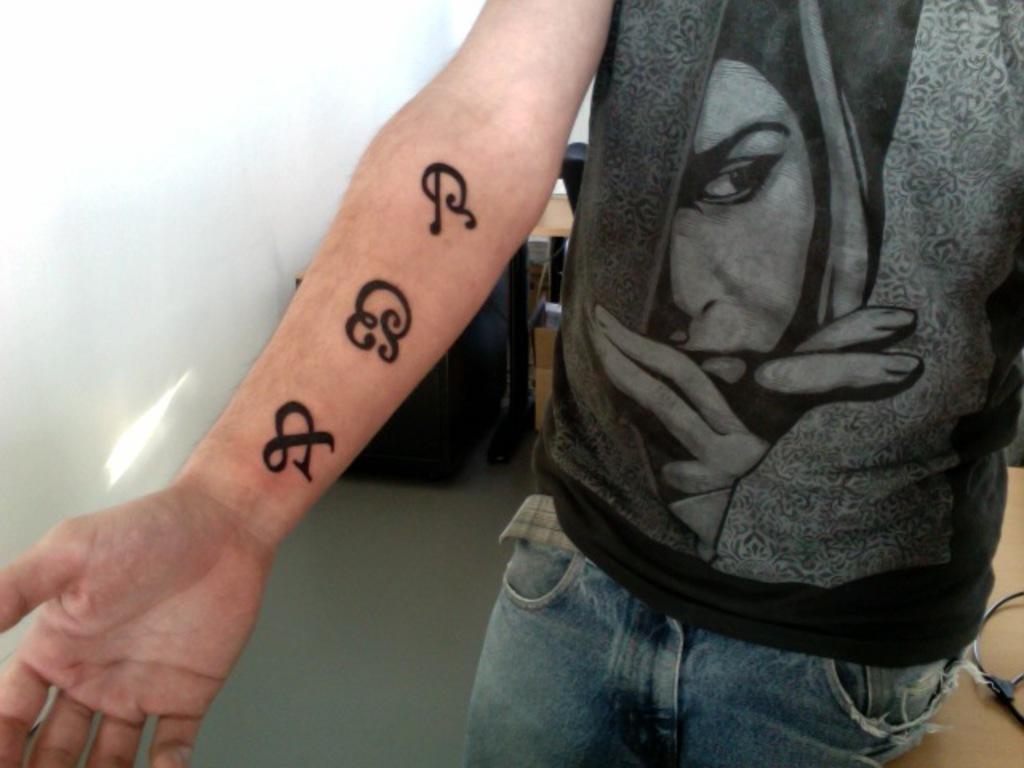Please provide a concise description of this image. In this picture, there is a person wearing a black t shirt and blue jeans. On his hand, there are tattoos. In the background, there are tables. 